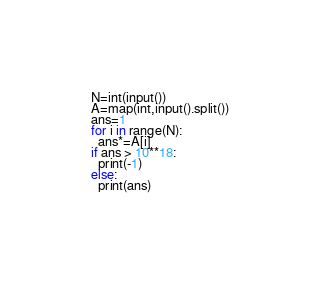<code> <loc_0><loc_0><loc_500><loc_500><_Python_>N=int(input())
A=map(int,input().split())
ans=1
for i in range(N):
  ans*=A[i]
if ans > 10**18:
  print(-1)
else:
  print(ans)</code> 